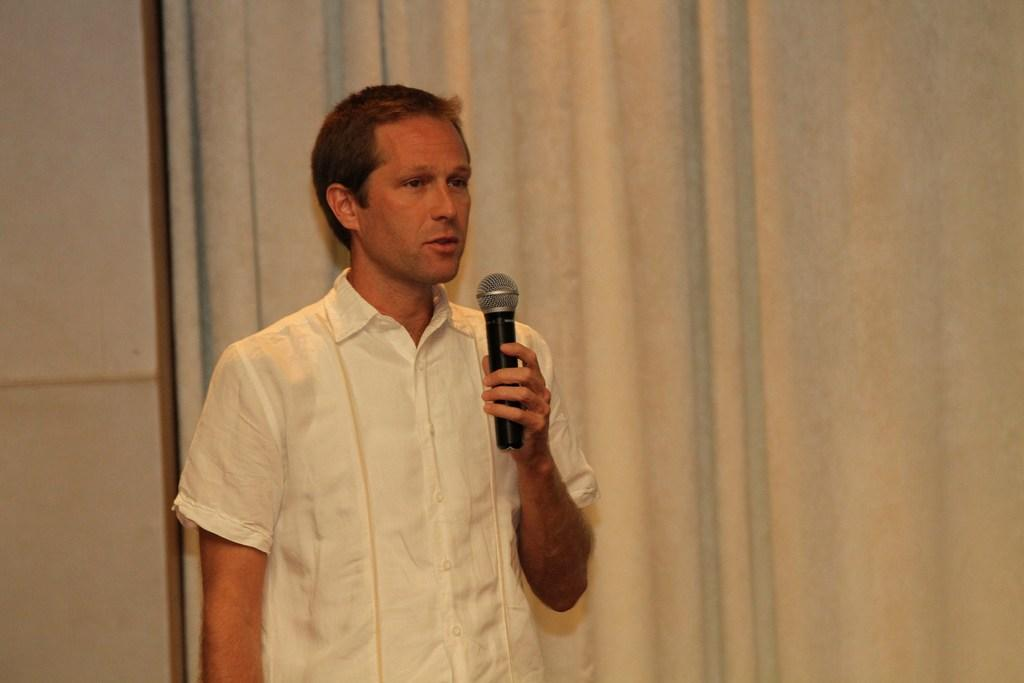What is the main subject of the image? The main subject of the image is a man standing in the center. What is the man holding in his hand? The man is holding a mic in his hand. What might the man be doing with the mic? The man may be talking or performing. What is the man wearing? The man is wearing a white shirt. What can be seen in the background of the image? There is a wall in the background of the image. How many brothers does the man have in the image? There is no information about the man's brothers in the image. What language is the man speaking in the image? There is no audio in the image, so it is impossible to determine the language being spoken. 